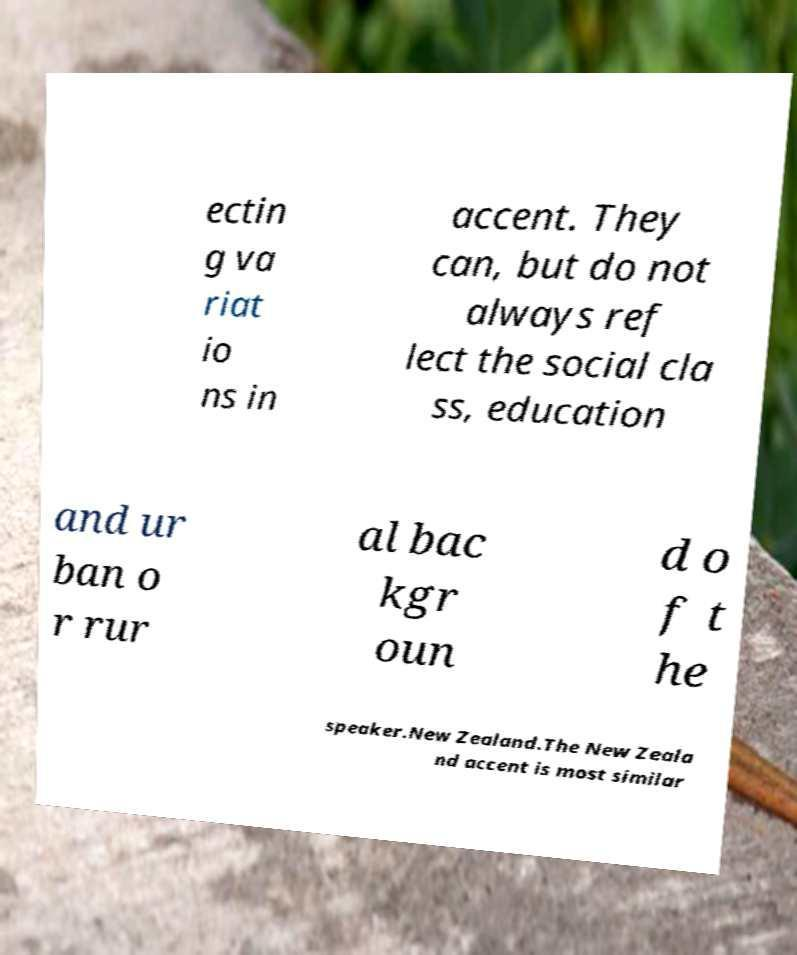I need the written content from this picture converted into text. Can you do that? ectin g va riat io ns in accent. They can, but do not always ref lect the social cla ss, education and ur ban o r rur al bac kgr oun d o f t he speaker.New Zealand.The New Zeala nd accent is most similar 